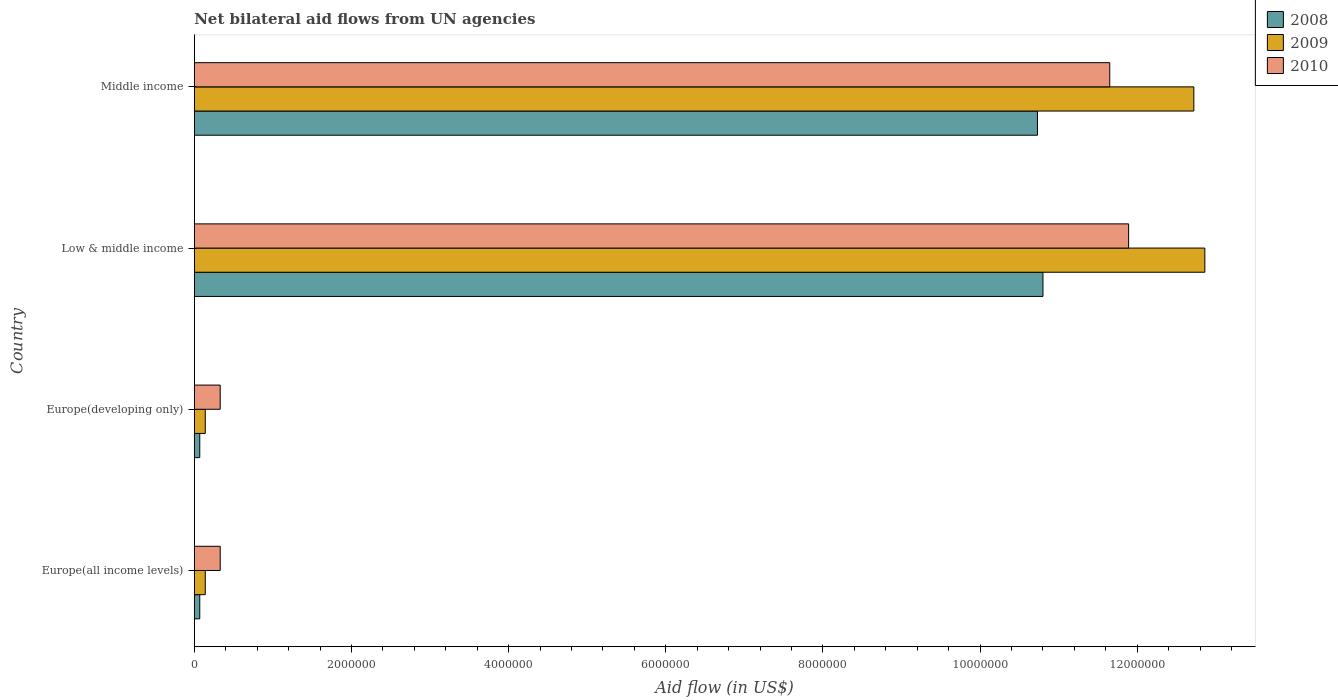How many different coloured bars are there?
Give a very brief answer. 3. What is the label of the 3rd group of bars from the top?
Ensure brevity in your answer.  Europe(developing only). What is the net bilateral aid flow in 2009 in Europe(developing only)?
Provide a succinct answer. 1.40e+05. Across all countries, what is the maximum net bilateral aid flow in 2008?
Provide a short and direct response. 1.08e+07. In which country was the net bilateral aid flow in 2008 minimum?
Your answer should be compact. Europe(all income levels). What is the total net bilateral aid flow in 2009 in the graph?
Keep it short and to the point. 2.59e+07. What is the difference between the net bilateral aid flow in 2008 in Europe(developing only) and that in Low & middle income?
Offer a terse response. -1.07e+07. What is the difference between the net bilateral aid flow in 2010 in Europe(developing only) and the net bilateral aid flow in 2008 in Low & middle income?
Ensure brevity in your answer.  -1.05e+07. What is the average net bilateral aid flow in 2010 per country?
Offer a terse response. 6.05e+06. What is the difference between the net bilateral aid flow in 2008 and net bilateral aid flow in 2010 in Middle income?
Provide a succinct answer. -9.20e+05. What is the ratio of the net bilateral aid flow in 2010 in Europe(all income levels) to that in Low & middle income?
Offer a very short reply. 0.03. Is the net bilateral aid flow in 2009 in Europe(all income levels) less than that in Europe(developing only)?
Provide a short and direct response. No. Is the difference between the net bilateral aid flow in 2008 in Europe(developing only) and Low & middle income greater than the difference between the net bilateral aid flow in 2010 in Europe(developing only) and Low & middle income?
Your response must be concise. Yes. What is the difference between the highest and the second highest net bilateral aid flow in 2009?
Your answer should be compact. 1.40e+05. What is the difference between the highest and the lowest net bilateral aid flow in 2008?
Your answer should be compact. 1.07e+07. In how many countries, is the net bilateral aid flow in 2010 greater than the average net bilateral aid flow in 2010 taken over all countries?
Your answer should be compact. 2. Is the sum of the net bilateral aid flow in 2009 in Europe(all income levels) and Middle income greater than the maximum net bilateral aid flow in 2008 across all countries?
Ensure brevity in your answer.  Yes. How many bars are there?
Ensure brevity in your answer.  12. How many countries are there in the graph?
Provide a short and direct response. 4. What is the difference between two consecutive major ticks on the X-axis?
Provide a succinct answer. 2.00e+06. Are the values on the major ticks of X-axis written in scientific E-notation?
Keep it short and to the point. No. Does the graph contain any zero values?
Offer a very short reply. No. Where does the legend appear in the graph?
Provide a succinct answer. Top right. How many legend labels are there?
Offer a terse response. 3. What is the title of the graph?
Ensure brevity in your answer.  Net bilateral aid flows from UN agencies. Does "1985" appear as one of the legend labels in the graph?
Provide a short and direct response. No. What is the label or title of the X-axis?
Offer a very short reply. Aid flow (in US$). What is the Aid flow (in US$) of 2009 in Europe(all income levels)?
Give a very brief answer. 1.40e+05. What is the Aid flow (in US$) of 2008 in Low & middle income?
Offer a terse response. 1.08e+07. What is the Aid flow (in US$) in 2009 in Low & middle income?
Offer a very short reply. 1.29e+07. What is the Aid flow (in US$) in 2010 in Low & middle income?
Provide a short and direct response. 1.19e+07. What is the Aid flow (in US$) of 2008 in Middle income?
Provide a short and direct response. 1.07e+07. What is the Aid flow (in US$) in 2009 in Middle income?
Keep it short and to the point. 1.27e+07. What is the Aid flow (in US$) of 2010 in Middle income?
Your answer should be very brief. 1.16e+07. Across all countries, what is the maximum Aid flow (in US$) in 2008?
Keep it short and to the point. 1.08e+07. Across all countries, what is the maximum Aid flow (in US$) in 2009?
Ensure brevity in your answer.  1.29e+07. Across all countries, what is the maximum Aid flow (in US$) of 2010?
Give a very brief answer. 1.19e+07. Across all countries, what is the minimum Aid flow (in US$) of 2009?
Offer a terse response. 1.40e+05. What is the total Aid flow (in US$) in 2008 in the graph?
Your answer should be very brief. 2.17e+07. What is the total Aid flow (in US$) of 2009 in the graph?
Provide a short and direct response. 2.59e+07. What is the total Aid flow (in US$) in 2010 in the graph?
Provide a short and direct response. 2.42e+07. What is the difference between the Aid flow (in US$) in 2009 in Europe(all income levels) and that in Europe(developing only)?
Ensure brevity in your answer.  0. What is the difference between the Aid flow (in US$) in 2008 in Europe(all income levels) and that in Low & middle income?
Your answer should be very brief. -1.07e+07. What is the difference between the Aid flow (in US$) of 2009 in Europe(all income levels) and that in Low & middle income?
Ensure brevity in your answer.  -1.27e+07. What is the difference between the Aid flow (in US$) in 2010 in Europe(all income levels) and that in Low & middle income?
Offer a very short reply. -1.16e+07. What is the difference between the Aid flow (in US$) in 2008 in Europe(all income levels) and that in Middle income?
Ensure brevity in your answer.  -1.07e+07. What is the difference between the Aid flow (in US$) in 2009 in Europe(all income levels) and that in Middle income?
Your response must be concise. -1.26e+07. What is the difference between the Aid flow (in US$) in 2010 in Europe(all income levels) and that in Middle income?
Provide a succinct answer. -1.13e+07. What is the difference between the Aid flow (in US$) in 2008 in Europe(developing only) and that in Low & middle income?
Offer a very short reply. -1.07e+07. What is the difference between the Aid flow (in US$) in 2009 in Europe(developing only) and that in Low & middle income?
Your answer should be very brief. -1.27e+07. What is the difference between the Aid flow (in US$) of 2010 in Europe(developing only) and that in Low & middle income?
Your answer should be very brief. -1.16e+07. What is the difference between the Aid flow (in US$) in 2008 in Europe(developing only) and that in Middle income?
Keep it short and to the point. -1.07e+07. What is the difference between the Aid flow (in US$) of 2009 in Europe(developing only) and that in Middle income?
Your response must be concise. -1.26e+07. What is the difference between the Aid flow (in US$) in 2010 in Europe(developing only) and that in Middle income?
Your answer should be very brief. -1.13e+07. What is the difference between the Aid flow (in US$) of 2010 in Low & middle income and that in Middle income?
Provide a succinct answer. 2.40e+05. What is the difference between the Aid flow (in US$) of 2009 in Europe(all income levels) and the Aid flow (in US$) of 2010 in Europe(developing only)?
Your answer should be very brief. -1.90e+05. What is the difference between the Aid flow (in US$) in 2008 in Europe(all income levels) and the Aid flow (in US$) in 2009 in Low & middle income?
Make the answer very short. -1.28e+07. What is the difference between the Aid flow (in US$) of 2008 in Europe(all income levels) and the Aid flow (in US$) of 2010 in Low & middle income?
Offer a terse response. -1.18e+07. What is the difference between the Aid flow (in US$) in 2009 in Europe(all income levels) and the Aid flow (in US$) in 2010 in Low & middle income?
Your response must be concise. -1.18e+07. What is the difference between the Aid flow (in US$) in 2008 in Europe(all income levels) and the Aid flow (in US$) in 2009 in Middle income?
Ensure brevity in your answer.  -1.26e+07. What is the difference between the Aid flow (in US$) of 2008 in Europe(all income levels) and the Aid flow (in US$) of 2010 in Middle income?
Your response must be concise. -1.16e+07. What is the difference between the Aid flow (in US$) in 2009 in Europe(all income levels) and the Aid flow (in US$) in 2010 in Middle income?
Offer a very short reply. -1.15e+07. What is the difference between the Aid flow (in US$) in 2008 in Europe(developing only) and the Aid flow (in US$) in 2009 in Low & middle income?
Ensure brevity in your answer.  -1.28e+07. What is the difference between the Aid flow (in US$) of 2008 in Europe(developing only) and the Aid flow (in US$) of 2010 in Low & middle income?
Ensure brevity in your answer.  -1.18e+07. What is the difference between the Aid flow (in US$) of 2009 in Europe(developing only) and the Aid flow (in US$) of 2010 in Low & middle income?
Offer a very short reply. -1.18e+07. What is the difference between the Aid flow (in US$) in 2008 in Europe(developing only) and the Aid flow (in US$) in 2009 in Middle income?
Keep it short and to the point. -1.26e+07. What is the difference between the Aid flow (in US$) of 2008 in Europe(developing only) and the Aid flow (in US$) of 2010 in Middle income?
Your response must be concise. -1.16e+07. What is the difference between the Aid flow (in US$) in 2009 in Europe(developing only) and the Aid flow (in US$) in 2010 in Middle income?
Provide a short and direct response. -1.15e+07. What is the difference between the Aid flow (in US$) in 2008 in Low & middle income and the Aid flow (in US$) in 2009 in Middle income?
Keep it short and to the point. -1.92e+06. What is the difference between the Aid flow (in US$) in 2008 in Low & middle income and the Aid flow (in US$) in 2010 in Middle income?
Make the answer very short. -8.50e+05. What is the difference between the Aid flow (in US$) of 2009 in Low & middle income and the Aid flow (in US$) of 2010 in Middle income?
Keep it short and to the point. 1.21e+06. What is the average Aid flow (in US$) of 2008 per country?
Provide a short and direct response. 5.42e+06. What is the average Aid flow (in US$) of 2009 per country?
Make the answer very short. 6.46e+06. What is the average Aid flow (in US$) in 2010 per country?
Provide a succinct answer. 6.05e+06. What is the difference between the Aid flow (in US$) of 2008 and Aid flow (in US$) of 2009 in Europe(developing only)?
Offer a very short reply. -7.00e+04. What is the difference between the Aid flow (in US$) in 2008 and Aid flow (in US$) in 2009 in Low & middle income?
Your answer should be very brief. -2.06e+06. What is the difference between the Aid flow (in US$) of 2008 and Aid flow (in US$) of 2010 in Low & middle income?
Your answer should be very brief. -1.09e+06. What is the difference between the Aid flow (in US$) of 2009 and Aid flow (in US$) of 2010 in Low & middle income?
Give a very brief answer. 9.70e+05. What is the difference between the Aid flow (in US$) in 2008 and Aid flow (in US$) in 2009 in Middle income?
Provide a succinct answer. -1.99e+06. What is the difference between the Aid flow (in US$) in 2008 and Aid flow (in US$) in 2010 in Middle income?
Make the answer very short. -9.20e+05. What is the difference between the Aid flow (in US$) of 2009 and Aid flow (in US$) of 2010 in Middle income?
Your answer should be compact. 1.07e+06. What is the ratio of the Aid flow (in US$) of 2008 in Europe(all income levels) to that in Europe(developing only)?
Your response must be concise. 1. What is the ratio of the Aid flow (in US$) in 2009 in Europe(all income levels) to that in Europe(developing only)?
Your answer should be compact. 1. What is the ratio of the Aid flow (in US$) in 2010 in Europe(all income levels) to that in Europe(developing only)?
Offer a very short reply. 1. What is the ratio of the Aid flow (in US$) of 2008 in Europe(all income levels) to that in Low & middle income?
Provide a succinct answer. 0.01. What is the ratio of the Aid flow (in US$) in 2009 in Europe(all income levels) to that in Low & middle income?
Provide a succinct answer. 0.01. What is the ratio of the Aid flow (in US$) of 2010 in Europe(all income levels) to that in Low & middle income?
Your response must be concise. 0.03. What is the ratio of the Aid flow (in US$) of 2008 in Europe(all income levels) to that in Middle income?
Ensure brevity in your answer.  0.01. What is the ratio of the Aid flow (in US$) of 2009 in Europe(all income levels) to that in Middle income?
Give a very brief answer. 0.01. What is the ratio of the Aid flow (in US$) in 2010 in Europe(all income levels) to that in Middle income?
Provide a short and direct response. 0.03. What is the ratio of the Aid flow (in US$) of 2008 in Europe(developing only) to that in Low & middle income?
Offer a terse response. 0.01. What is the ratio of the Aid flow (in US$) in 2009 in Europe(developing only) to that in Low & middle income?
Your answer should be very brief. 0.01. What is the ratio of the Aid flow (in US$) in 2010 in Europe(developing only) to that in Low & middle income?
Provide a succinct answer. 0.03. What is the ratio of the Aid flow (in US$) in 2008 in Europe(developing only) to that in Middle income?
Give a very brief answer. 0.01. What is the ratio of the Aid flow (in US$) in 2009 in Europe(developing only) to that in Middle income?
Ensure brevity in your answer.  0.01. What is the ratio of the Aid flow (in US$) in 2010 in Europe(developing only) to that in Middle income?
Your answer should be very brief. 0.03. What is the ratio of the Aid flow (in US$) in 2009 in Low & middle income to that in Middle income?
Keep it short and to the point. 1.01. What is the ratio of the Aid flow (in US$) of 2010 in Low & middle income to that in Middle income?
Your answer should be very brief. 1.02. What is the difference between the highest and the lowest Aid flow (in US$) in 2008?
Give a very brief answer. 1.07e+07. What is the difference between the highest and the lowest Aid flow (in US$) in 2009?
Your answer should be very brief. 1.27e+07. What is the difference between the highest and the lowest Aid flow (in US$) in 2010?
Ensure brevity in your answer.  1.16e+07. 